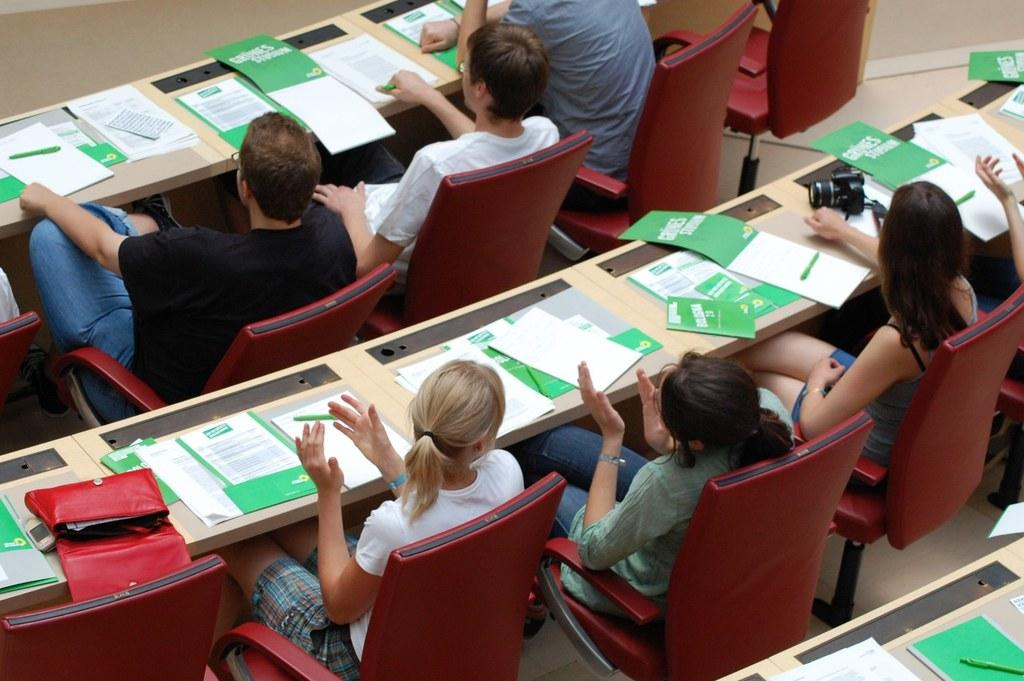What are the people in the image doing? The persons in the image are sitting on chairs around a table. What items can be seen on the table? There are books, pens, a handbag, and a camera on the table. What might the people be using the pens for? The pens might be used for writing or taking notes, given the presence of books on the table. What type of bag is on the table? There is a handbag on the table. How many pigs are visible in the image? There are no pigs present in the image. What type of truck is parked near the table in the image? There is no truck present in the image. 